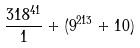Convert formula to latex. <formula><loc_0><loc_0><loc_500><loc_500>\frac { 3 1 8 ^ { 4 1 } } { 1 } + ( 9 ^ { 2 1 3 } + 1 0 )</formula> 